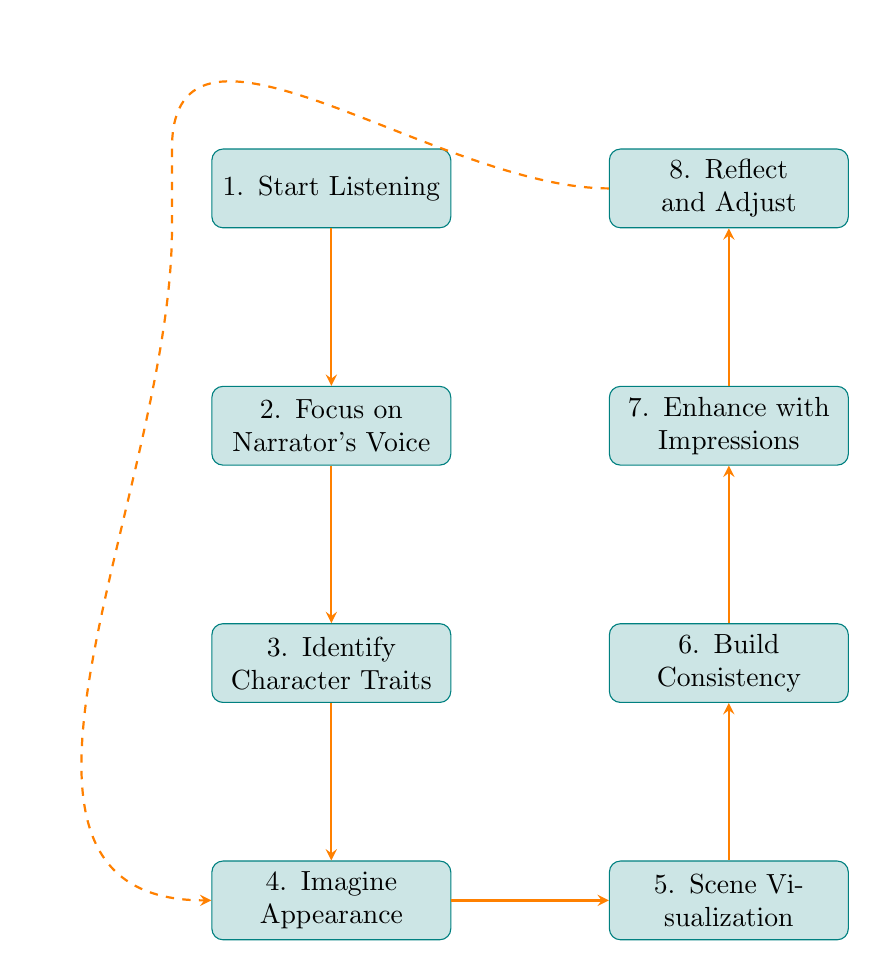What is the first step in the flow chart? The first step in the flow chart is labeled "Start Listening." This is located at the topmost node, indicating the initial action to take before progressing through the rest of the steps.
Answer: Start Listening How many nodes are present in the diagram? The diagram contains a total of eight nodes. Each step in the process of visualizing characters while listening to an audio book is represented by a node.
Answer: Eight What is the last step shown in the flow chart? The last step shown in the flow chart is labeled "Reflect and Adjust," which appears at the top of the flow diagram, indicating the final action to consider after completing the prior steps.
Answer: Reflect and Adjust Which two steps are adjacent to "Scene Visualization"? The two steps adjacent to "Scene Visualization" are "Imagine Appearance" (on the left) and "Build Consistency" (above). This adjacency indicates that these steps are sequential in the process of character visualization.
Answer: Imagine Appearance, Build Consistency What is the relationship between "Enhance with Impressions" and the other steps? "Enhance with Impressions" is directly above "Build Consistency," indicating a sequence where impressions are augmented before reflecting and adjusting the visualizations. It connects the emotional detail enhancement with the consistency building step.
Answer: Directly above Build Consistency What should you do after you "Identify Character Traits"? After "Identify Character Traits," the next step is to "Imagine Appearance." This shows a logical flow where understanding character traits leads to visualizing their physical attributes based on descriptions provided in the audio book.
Answer: Imagine Appearance What kind of visualizations should you maintain as the story progresses? You should maintain a consistent image of the characters and settings. This step emphasizes the importance of continuity and coherence in the mental images you create while listening to the book.
Answer: Consistent image Which step allows for adjustments to visualizations? The step that allows for adjustments to visualizations is "Reflect and Adjust." This indicates that as new information is presented in the audio book, you should refine your mental images of the characters and scenes.
Answer: Reflect and Adjust 